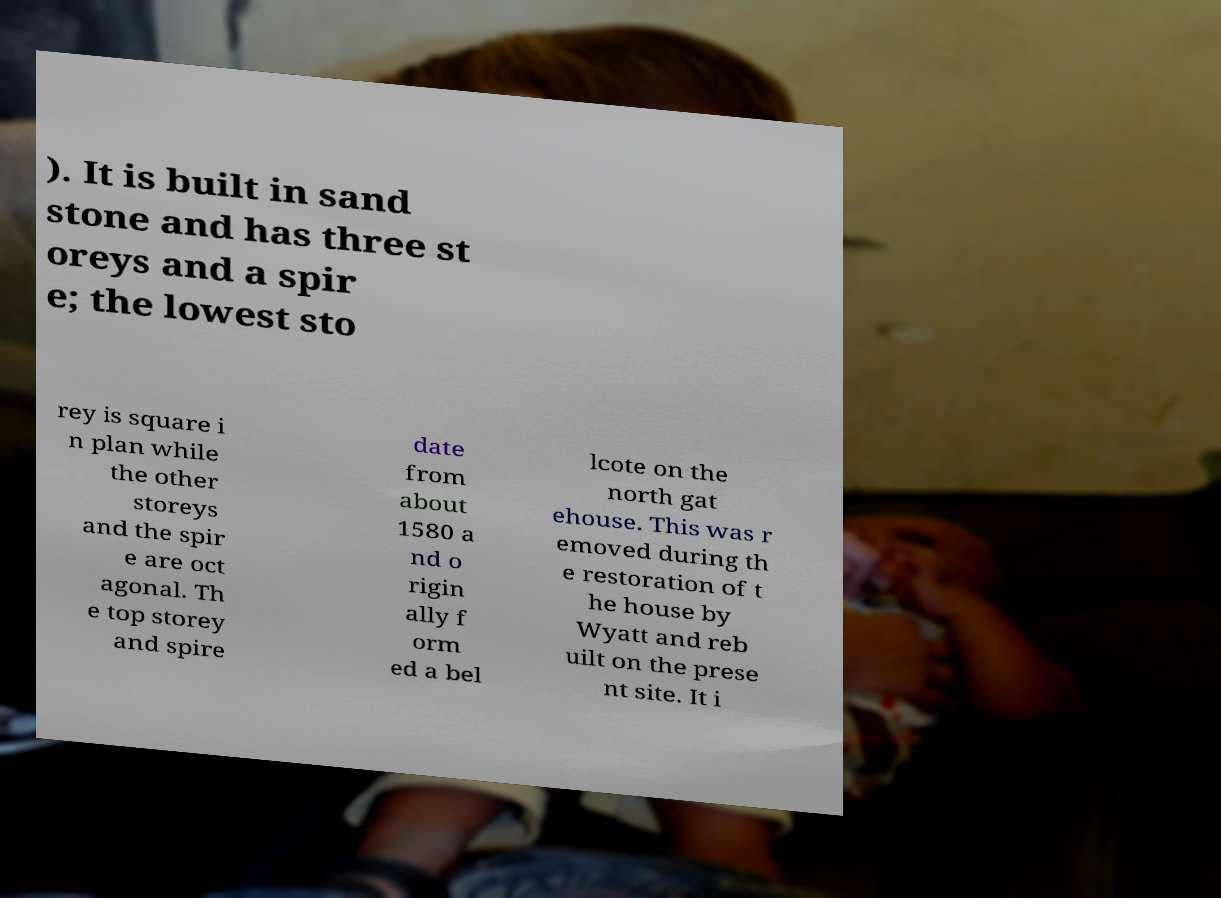Please identify and transcribe the text found in this image. ). It is built in sand stone and has three st oreys and a spir e; the lowest sto rey is square i n plan while the other storeys and the spir e are oct agonal. Th e top storey and spire date from about 1580 a nd o rigin ally f orm ed a bel lcote on the north gat ehouse. This was r emoved during th e restoration of t he house by Wyatt and reb uilt on the prese nt site. It i 